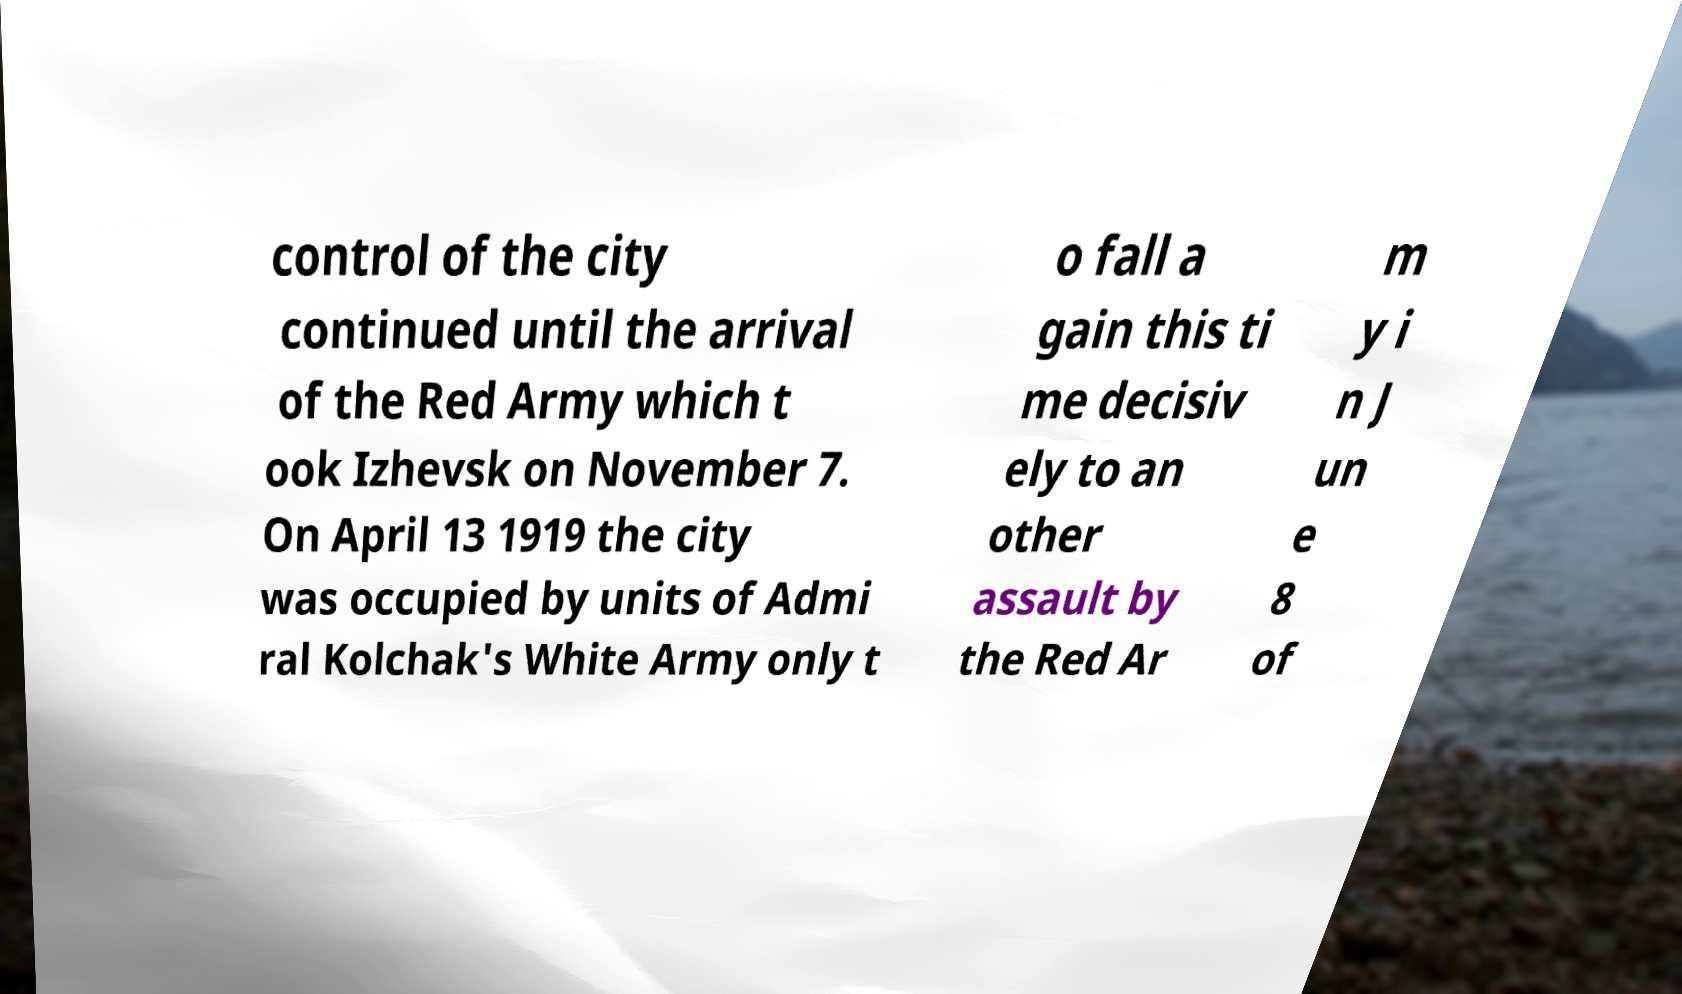Could you extract and type out the text from this image? control of the city continued until the arrival of the Red Army which t ook Izhevsk on November 7. On April 13 1919 the city was occupied by units of Admi ral Kolchak's White Army only t o fall a gain this ti me decisiv ely to an other assault by the Red Ar m y i n J un e 8 of 